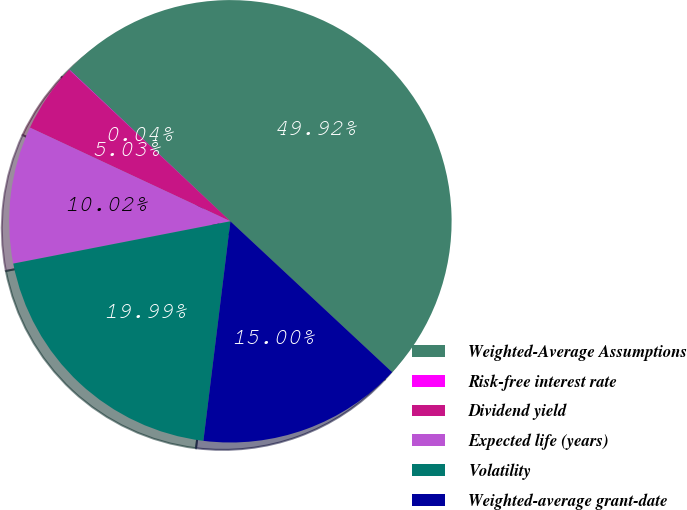Convert chart to OTSL. <chart><loc_0><loc_0><loc_500><loc_500><pie_chart><fcel>Weighted-Average Assumptions<fcel>Risk-free interest rate<fcel>Dividend yield<fcel>Expected life (years)<fcel>Volatility<fcel>Weighted-average grant-date<nl><fcel>49.92%<fcel>0.04%<fcel>5.03%<fcel>10.02%<fcel>19.99%<fcel>15.0%<nl></chart> 